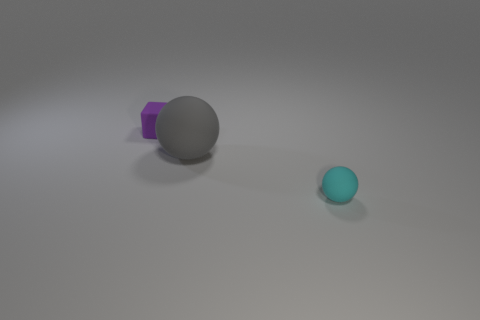Add 3 small green rubber cubes. How many objects exist? 6 Subtract all cyan balls. How many balls are left? 1 Subtract 0 purple spheres. How many objects are left? 3 Subtract all balls. How many objects are left? 1 Subtract all purple spheres. Subtract all cyan cubes. How many spheres are left? 2 Subtract all large gray matte balls. Subtract all tiny spheres. How many objects are left? 1 Add 1 cyan matte objects. How many cyan matte objects are left? 2 Add 2 big objects. How many big objects exist? 3 